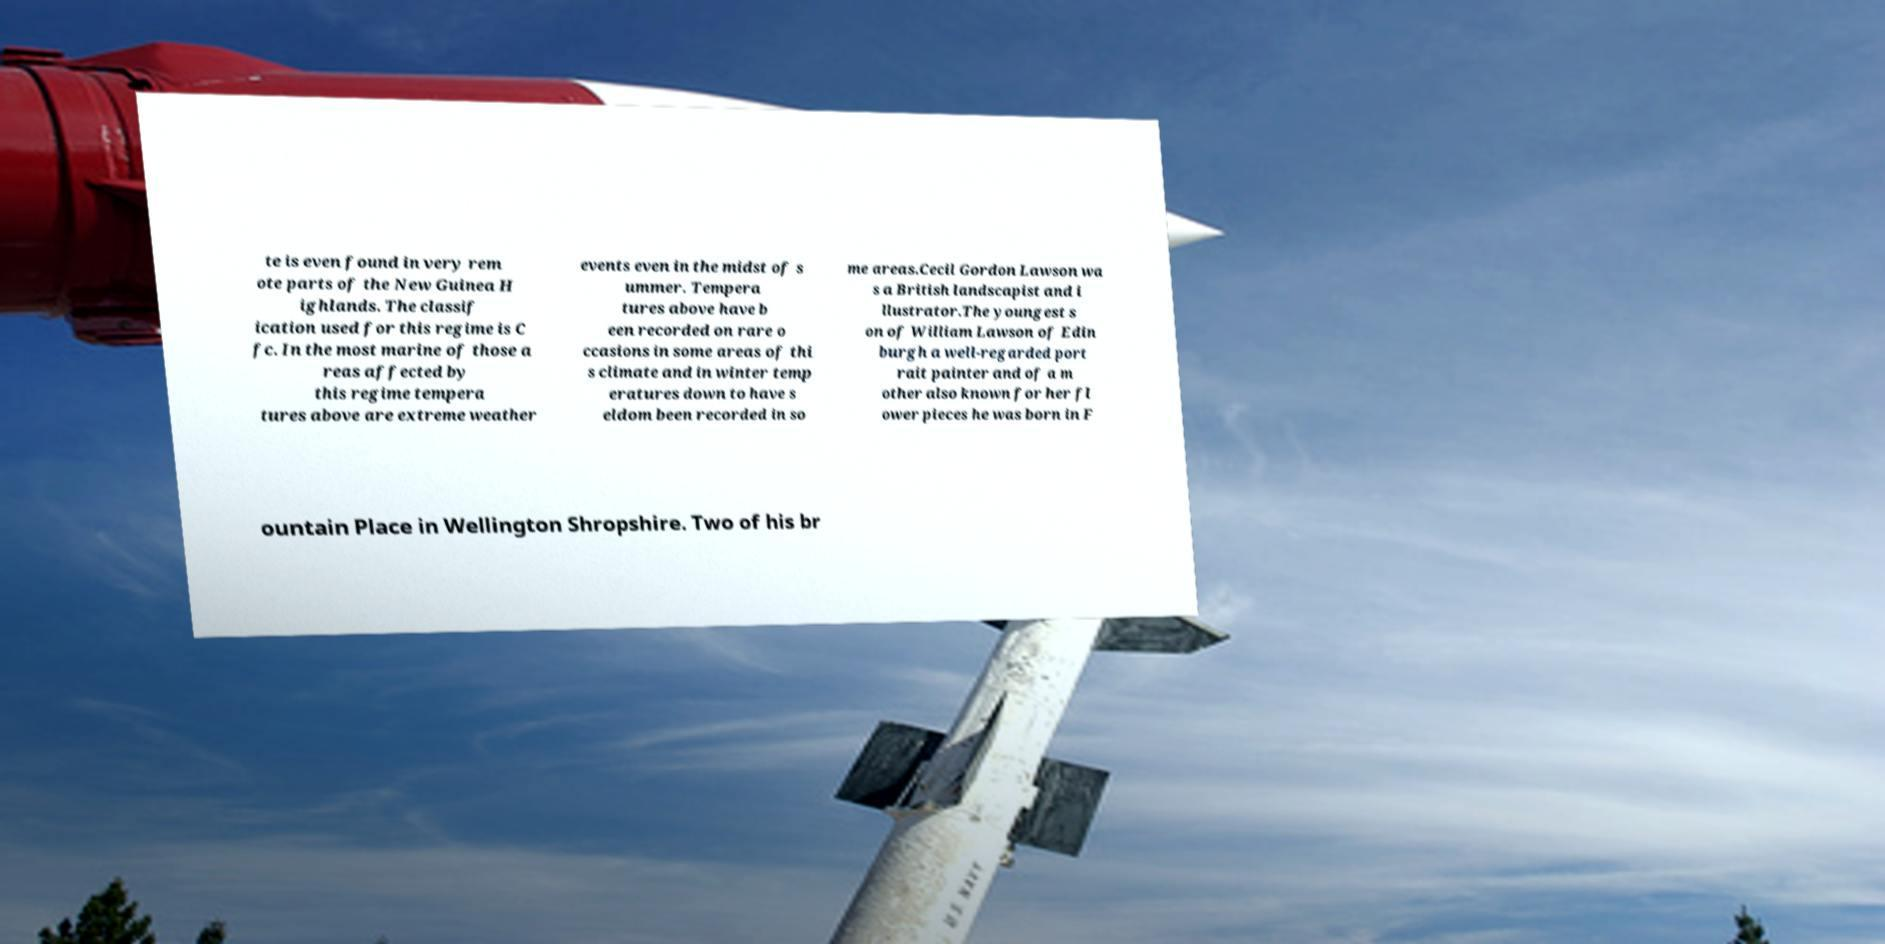Please identify and transcribe the text found in this image. te is even found in very rem ote parts of the New Guinea H ighlands. The classif ication used for this regime is C fc. In the most marine of those a reas affected by this regime tempera tures above are extreme weather events even in the midst of s ummer. Tempera tures above have b een recorded on rare o ccasions in some areas of thi s climate and in winter temp eratures down to have s eldom been recorded in so me areas.Cecil Gordon Lawson wa s a British landscapist and i llustrator.The youngest s on of William Lawson of Edin burgh a well-regarded port rait painter and of a m other also known for her fl ower pieces he was born in F ountain Place in Wellington Shropshire. Two of his br 